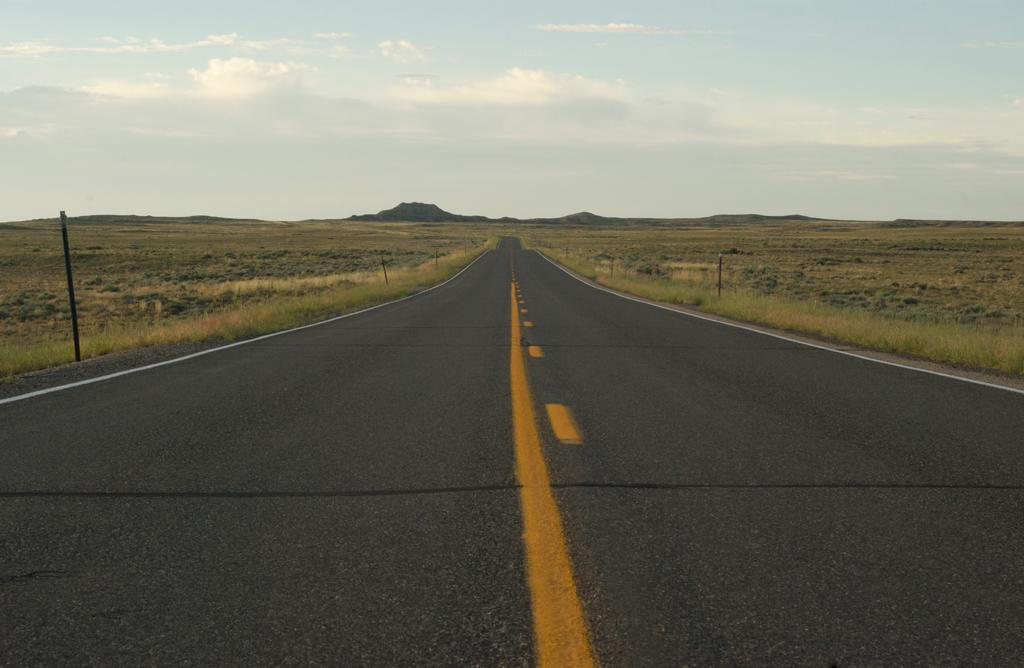What is the main feature of the image? There is a road in the image. What type of vegetation can be seen beside the road? There is grass visible in the image. What structures are present beside the road? There are poles visible in the image. What can be seen in the distance in the image? There are hills visible in the background of the image. How would you describe the weather in the image? The sky is visible in the image and appears cloudy. Where is the arch located in the image? There is no arch present in the image. What type of garden can be seen in the image? There is no garden present in the image. 